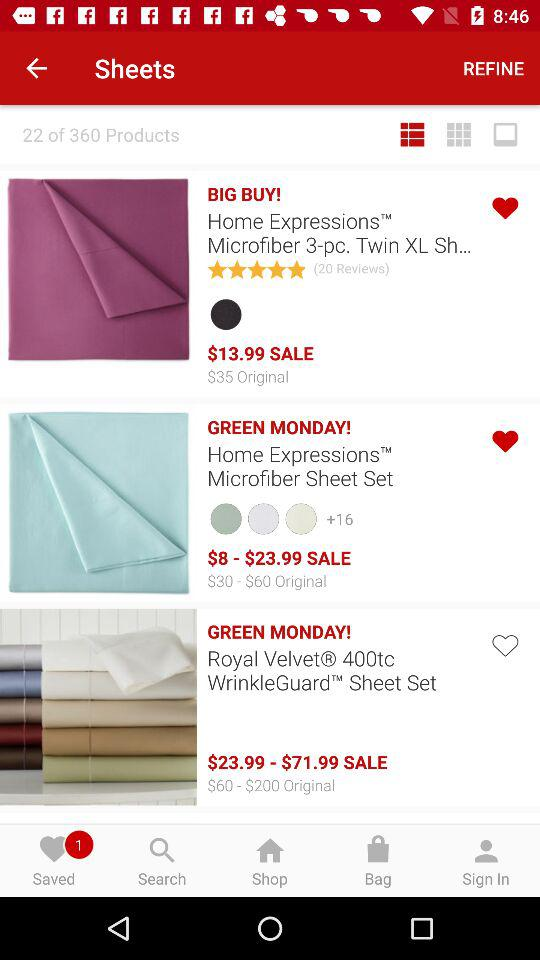How much is the most expensive item on sale? The most expensive item currently on sale is the Royal Velvet 400tc WrinkleGuard Sheet Set, with a promotional price range of $23.99 to $71.99, depending on the specific size and options you choose. 